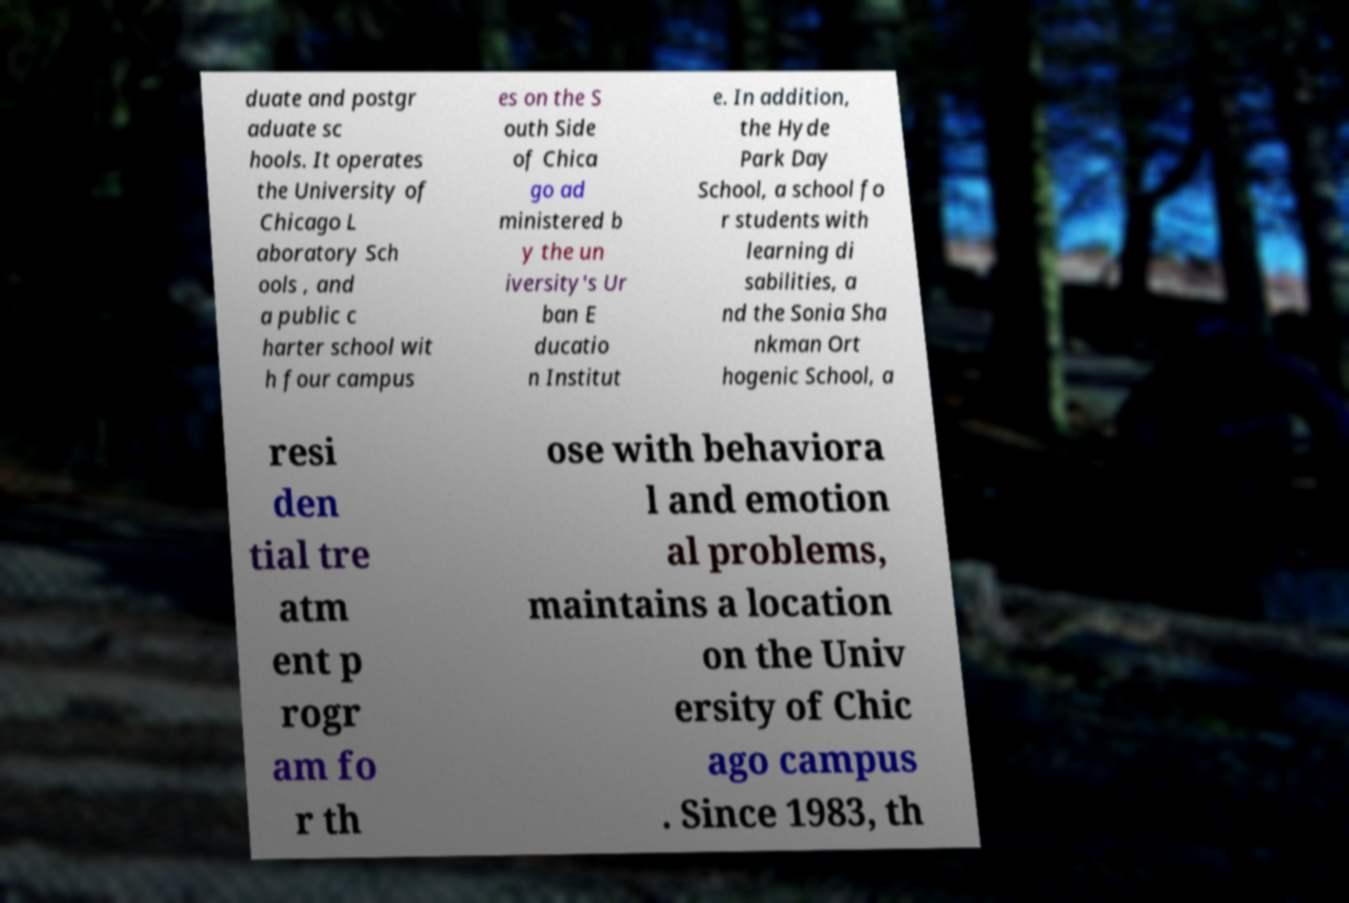I need the written content from this picture converted into text. Can you do that? duate and postgr aduate sc hools. It operates the University of Chicago L aboratory Sch ools , and a public c harter school wit h four campus es on the S outh Side of Chica go ad ministered b y the un iversity's Ur ban E ducatio n Institut e. In addition, the Hyde Park Day School, a school fo r students with learning di sabilities, a nd the Sonia Sha nkman Ort hogenic School, a resi den tial tre atm ent p rogr am fo r th ose with behaviora l and emotion al problems, maintains a location on the Univ ersity of Chic ago campus . Since 1983, th 